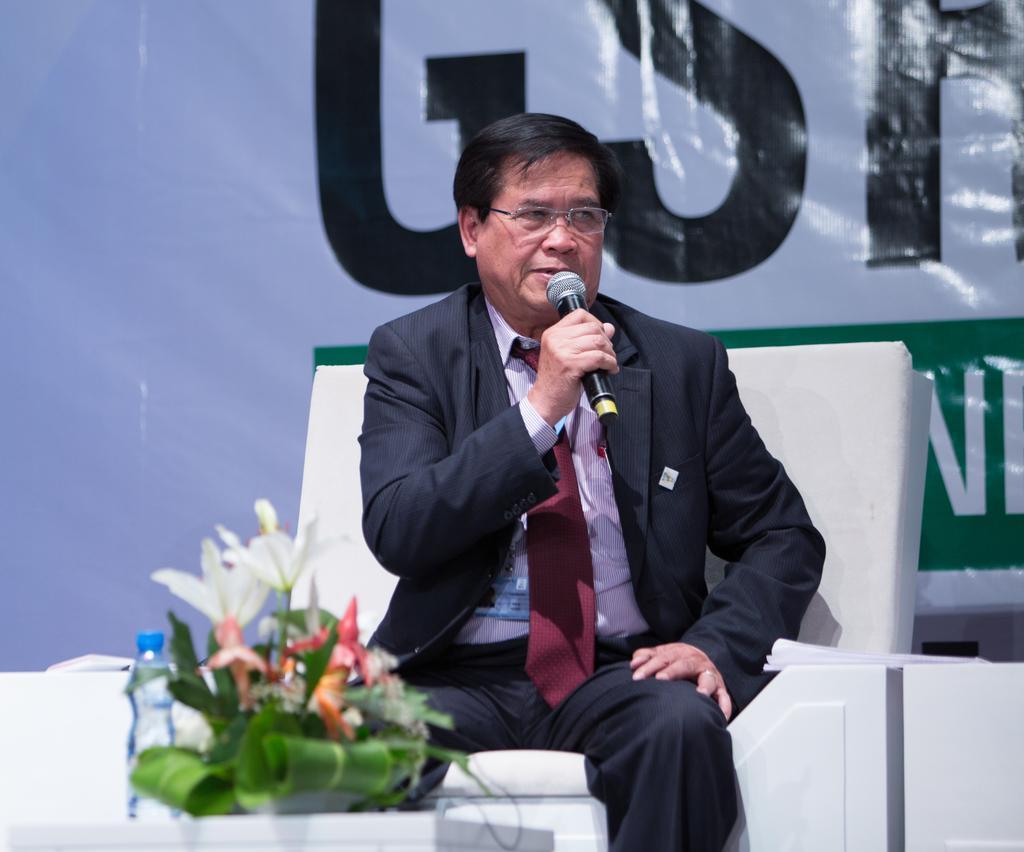Could you give a brief overview of what you see in this image? In the picture I can see a man is sitting and holding a microphone in the hand. I can also see a bottle and flowers on a white color object. In the background I can see a banner which has something written on it. 